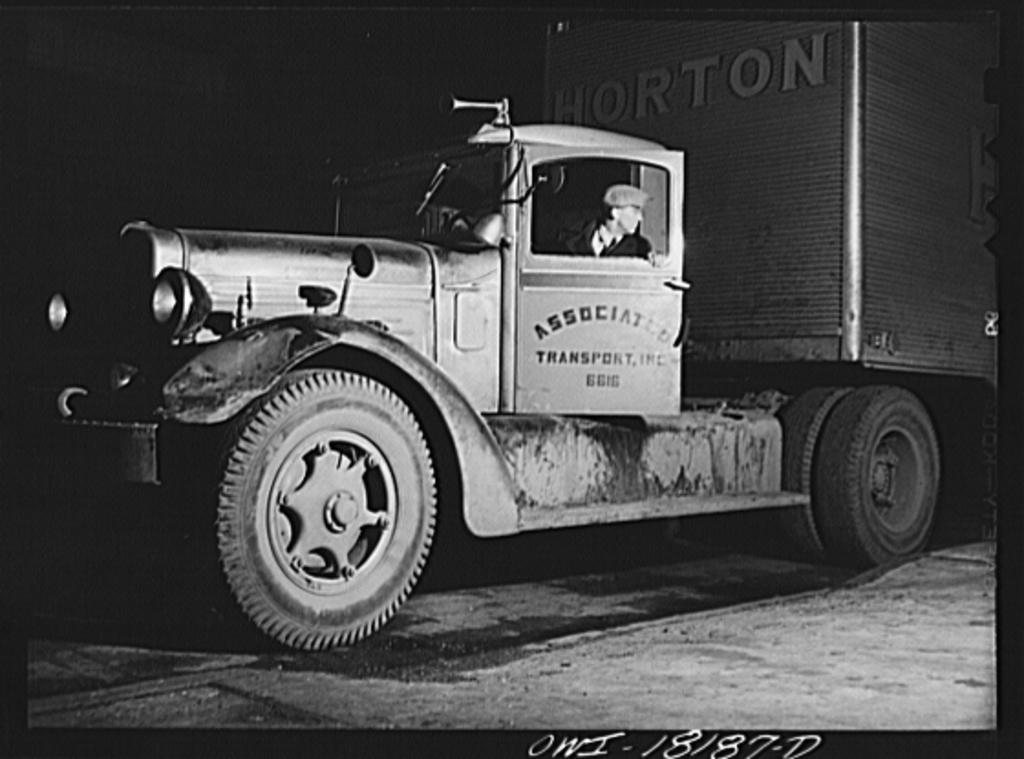How would you summarize this image in a sentence or two? In this picture we can see a vehicle on the road with a person in it and in the background we can see it is dark, at the bottom we can see some text. 